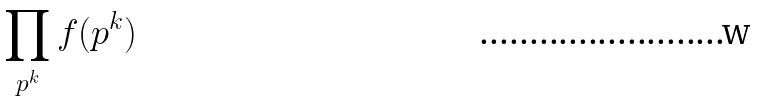Convert formula to latex. <formula><loc_0><loc_0><loc_500><loc_500>\prod _ { p ^ { k } } f ( p ^ { k } )</formula> 